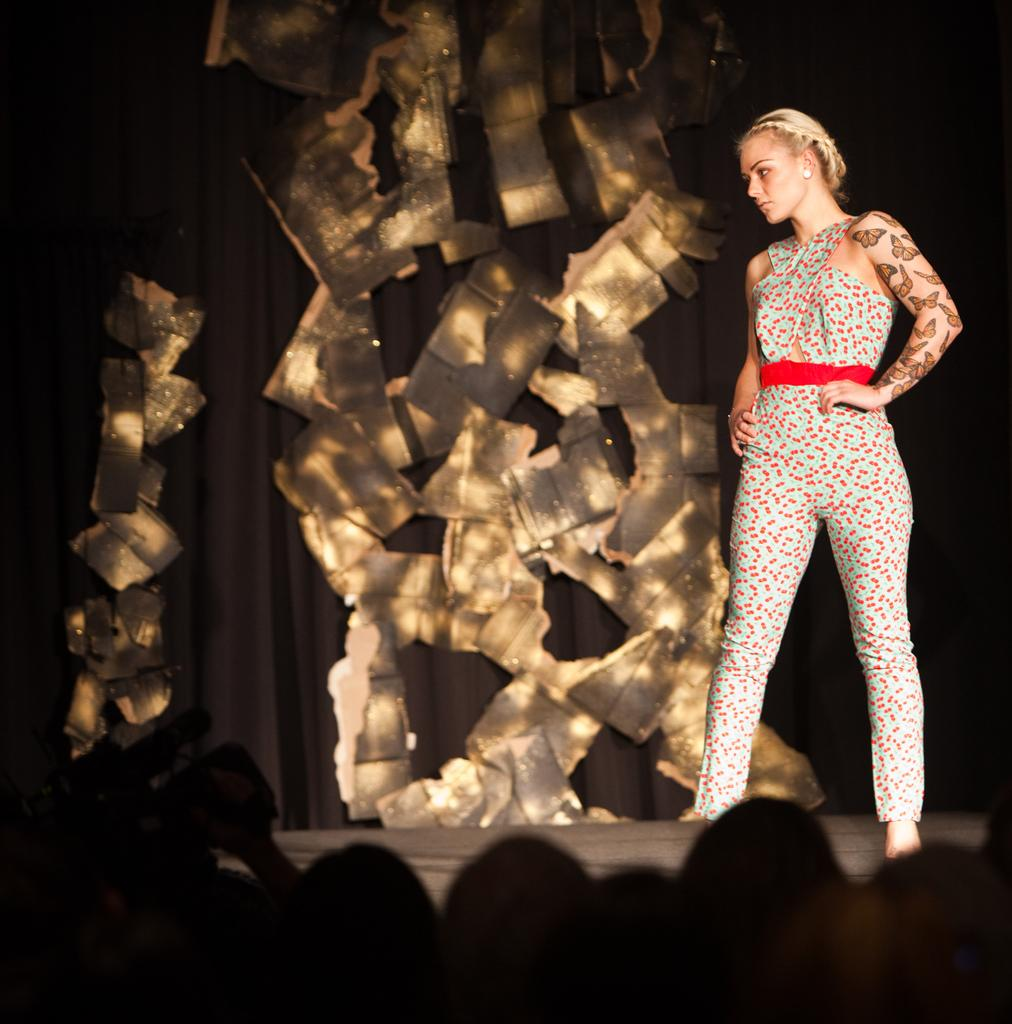What is the woman doing in the image? The woman is standing on the stage. Where are the people located in the image? The people are at the bottom of the image. Can you describe the person on the left side of the image? There is a person holding a camera on the left side of the image. Reasoning: Let' Let's think step by step in order to produce the conversation. We start by identifying the main subjects and objects in the image based on the provided facts. We then formulate questions that focus on the actions and locations of these subjects and objects, ensuring that each question can be answered definitively with the information given. We avoid yes/no questions and ensure that the language is simple and clear. Absurd Question/Answer: What type of seed is being planted by the woman on the stage? There is no seed or planting activity present in the image; the woman is simply standing on the stage. How many rings can be seen on the fingers of the people at the bottom of the image? There is no information about rings or fingers of the people at the bottom of the image, as the focus is on their location and not their attire or accessories. What type of street can be seen in the image? There is no street present in the image; it features a woman standing on a stage and people at the bottom of the image. 